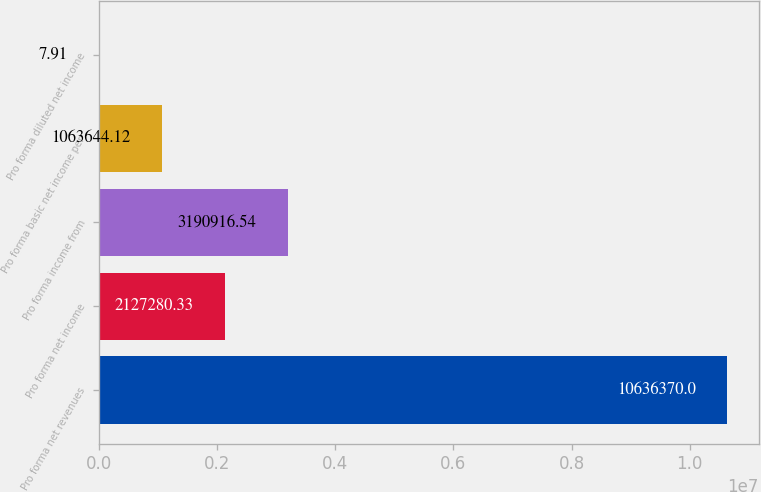<chart> <loc_0><loc_0><loc_500><loc_500><bar_chart><fcel>Pro forma net revenues<fcel>Pro forma net income<fcel>Pro forma income from<fcel>Pro forma basic net income per<fcel>Pro forma diluted net income<nl><fcel>1.06364e+07<fcel>2.12728e+06<fcel>3.19092e+06<fcel>1.06364e+06<fcel>7.91<nl></chart> 